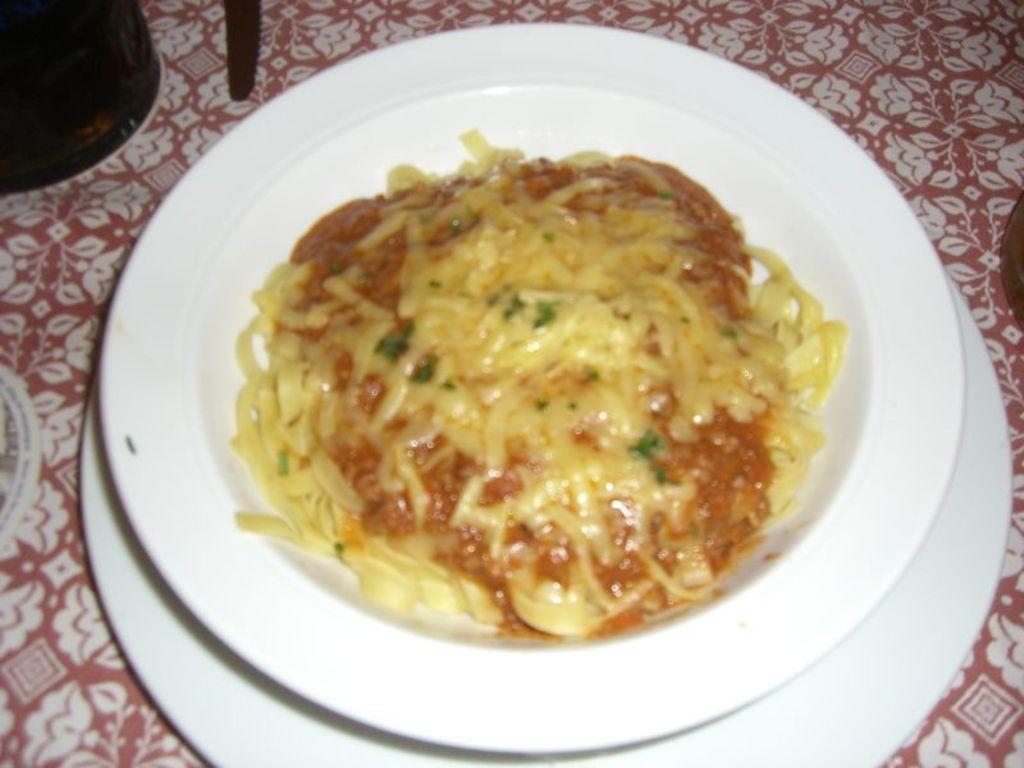What is the main subject of the image? There is a food item in the image. How is the food item presented? The food item is on a plate. Is there any additional information about the plate setup? Yes, there is another plate underneath the first plate. What type of print can be seen on the appliances in the image? There are no appliances present in the image, so it is not possible to determine if there is any print on them. 